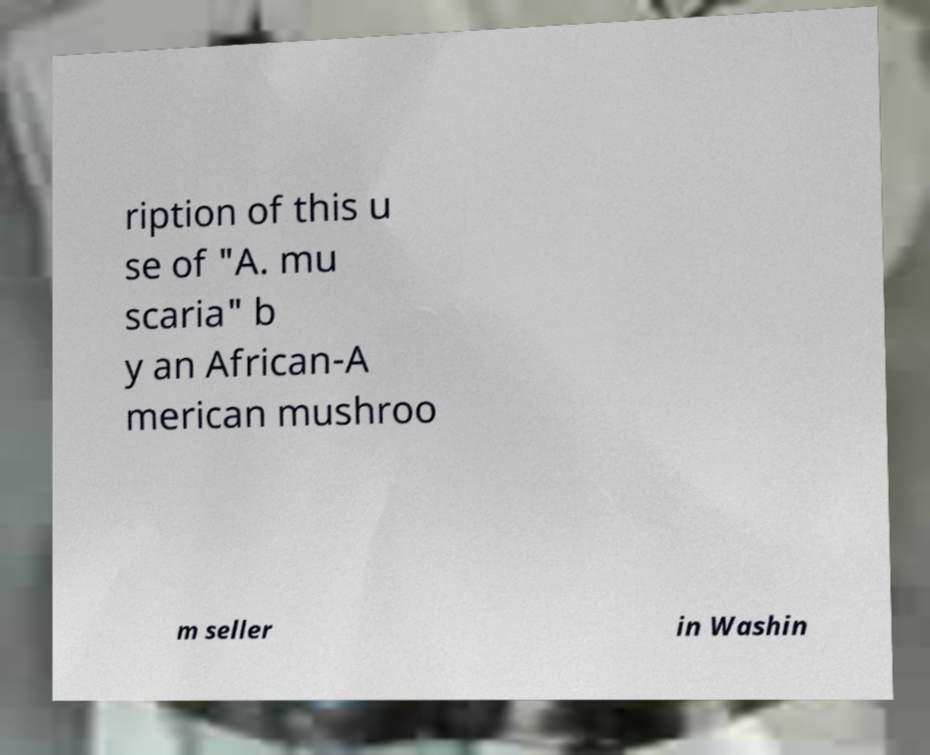Can you accurately transcribe the text from the provided image for me? ription of this u se of "A. mu scaria" b y an African-A merican mushroo m seller in Washin 